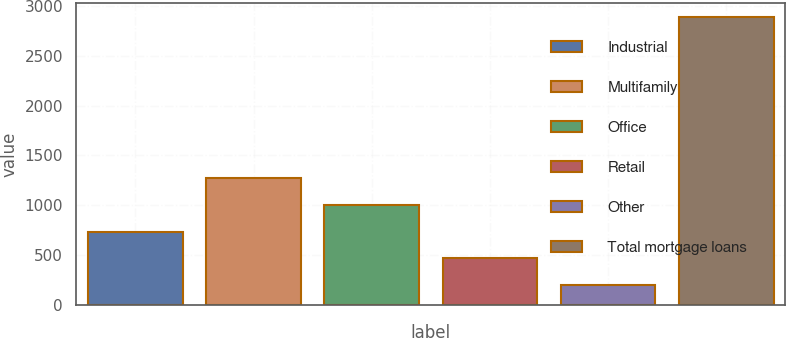Convert chart to OTSL. <chart><loc_0><loc_0><loc_500><loc_500><bar_chart><fcel>Industrial<fcel>Multifamily<fcel>Office<fcel>Retail<fcel>Other<fcel>Total mortgage loans<nl><fcel>737.2<fcel>1274.4<fcel>1005.8<fcel>468.6<fcel>200<fcel>2886<nl></chart> 